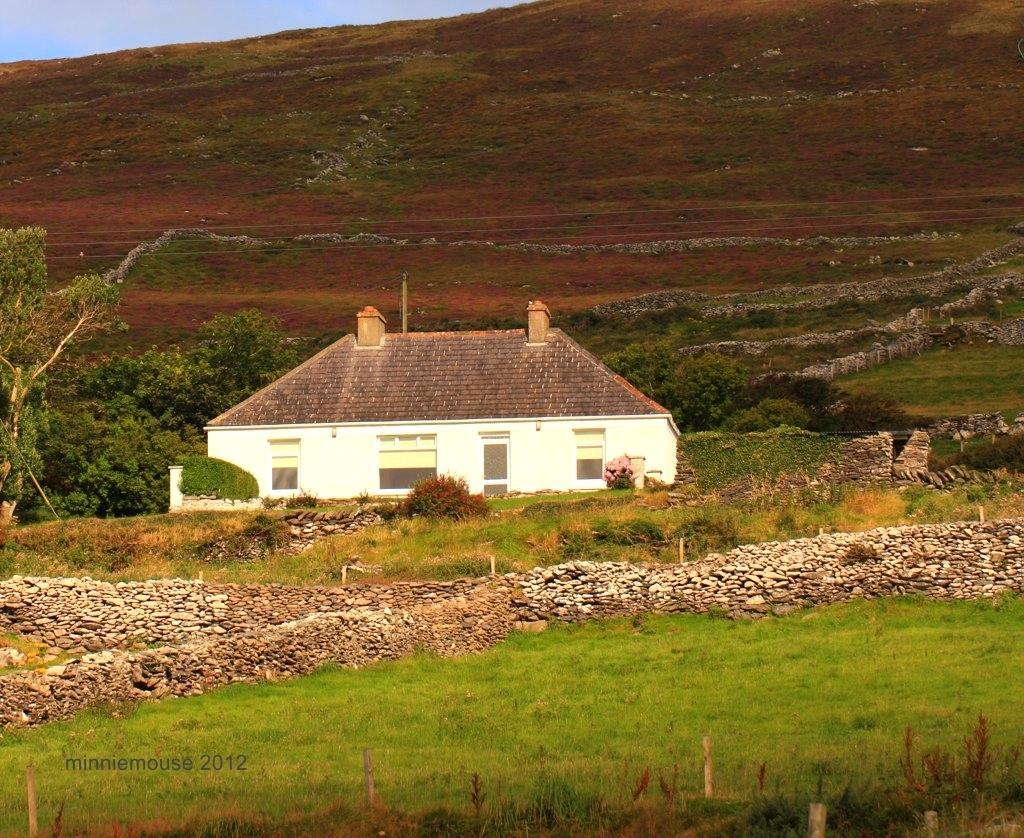How would you summarize this image in a sentence or two? In this image there are fields and rock walls, in the background there is a house, trees and a mountain. 